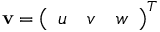<formula> <loc_0><loc_0><loc_500><loc_500>{ v } = { \left ( \begin{array} { l l l } { u } & { v } & { w } \end{array} \right ) } ^ { T }</formula> 